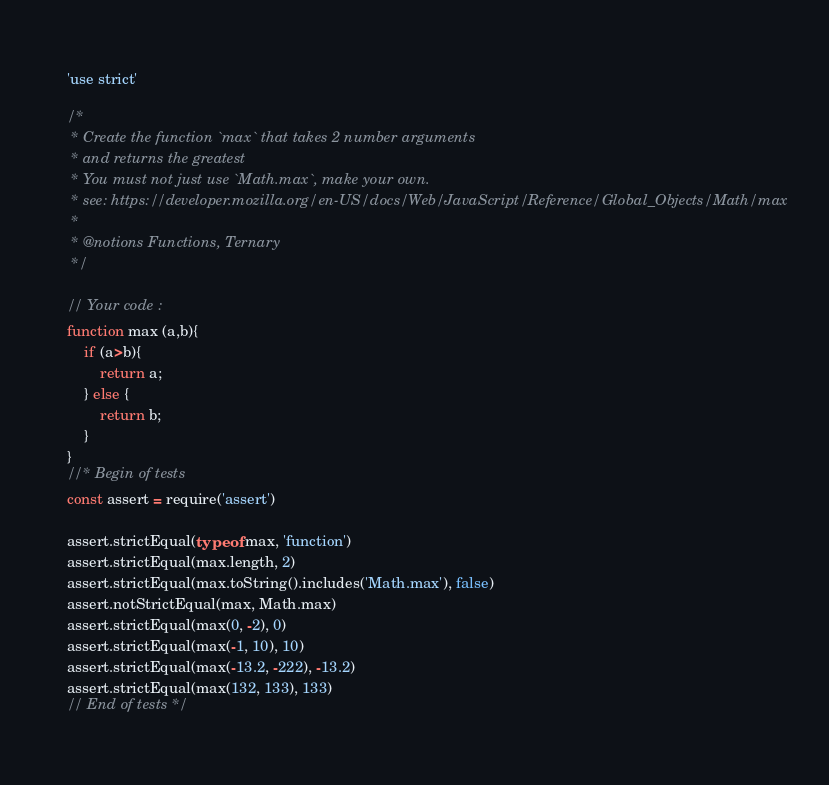<code> <loc_0><loc_0><loc_500><loc_500><_JavaScript_>'use strict'

/*
 * Create the function `max` that takes 2 number arguments
 * and returns the greatest
 * You must not just use `Math.max`, make your own.
 * see: https://developer.mozilla.org/en-US/docs/Web/JavaScript/Reference/Global_Objects/Math/max
 *
 * @notions Functions, Ternary
 */

// Your code :
function max (a,b){
    if (a>b){
        return a;
    } else {
        return b;
    }
}
//* Begin of tests
const assert = require('assert')

assert.strictEqual(typeof max, 'function')
assert.strictEqual(max.length, 2)
assert.strictEqual(max.toString().includes('Math.max'), false)
assert.notStrictEqual(max, Math.max)
assert.strictEqual(max(0, -2), 0)
assert.strictEqual(max(-1, 10), 10)
assert.strictEqual(max(-13.2, -222), -13.2)
assert.strictEqual(max(132, 133), 133)
// End of tests */
</code> 